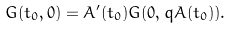<formula> <loc_0><loc_0><loc_500><loc_500>G ( t _ { 0 } , 0 ) = A ^ { \prime } ( t _ { 0 } ) G ( 0 , q A ( t _ { 0 } ) ) .</formula> 